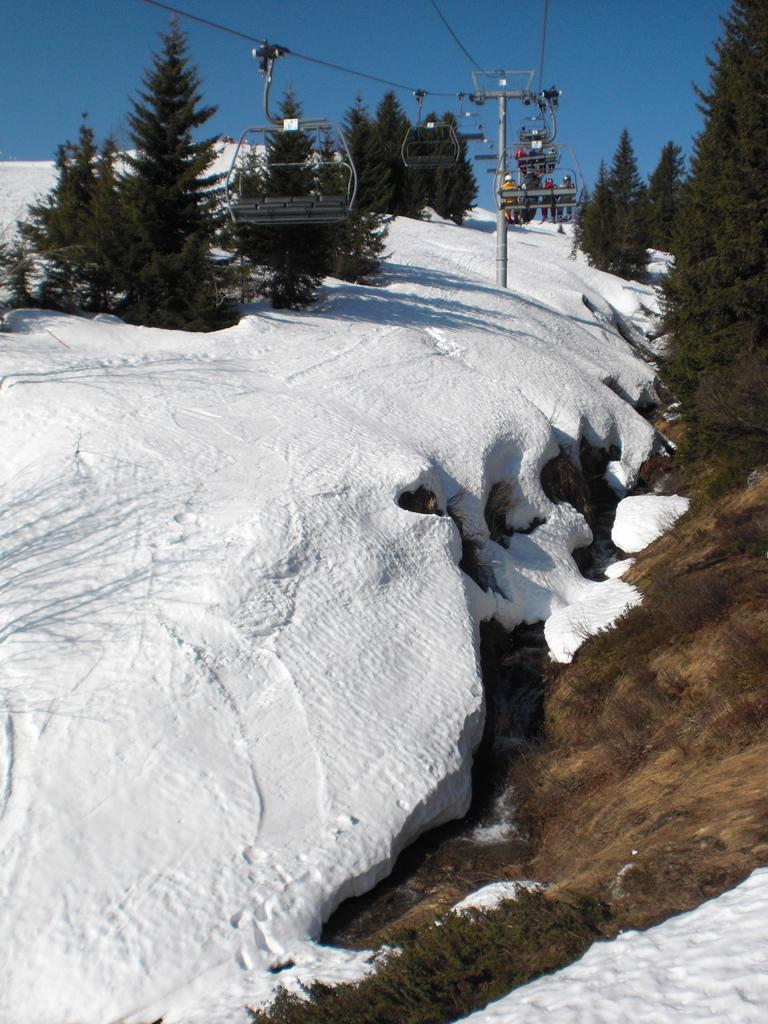What is the condition of the ground in the image? The ground is covered in snow. What type of natural elements can be seen in the image? There are trees in the image. What type of transportation is present in the image? Rope ways are present in the image. What other objects can be seen in the image? Wires and a pole are visible in the image. What is visible in the background of the image? The sky is visible in the background of the image. Can you see a tub filled with yams in the image? There is no tub filled with yams present in the image. Is there an owl perched on one of the trees in the image? There is no owl visible in the image. 